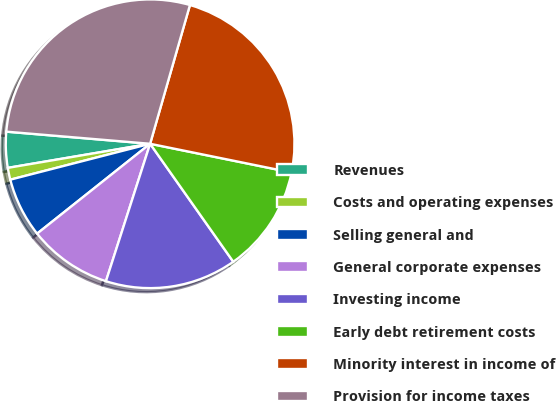Convert chart. <chart><loc_0><loc_0><loc_500><loc_500><pie_chart><fcel>Revenues<fcel>Costs and operating expenses<fcel>Selling general and<fcel>General corporate expenses<fcel>Investing income<fcel>Early debt retirement costs<fcel>Minority interest in income of<fcel>Provision for income taxes<nl><fcel>4.01%<fcel>1.33%<fcel>6.69%<fcel>9.36%<fcel>14.72%<fcel>12.04%<fcel>23.74%<fcel>28.11%<nl></chart> 